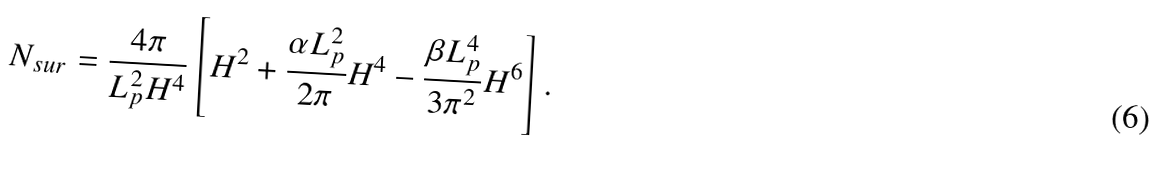Convert formula to latex. <formula><loc_0><loc_0><loc_500><loc_500>N _ { s u r } = \frac { 4 \pi } { L _ { p } ^ { 2 } H ^ { 4 } } \left [ H ^ { 2 } + \frac { \alpha L _ { p } ^ { 2 } } { 2 \pi } H ^ { 4 } - \frac { \beta L _ { p } ^ { 4 } } { 3 \pi ^ { 2 } } H ^ { 6 } \right ] .</formula> 